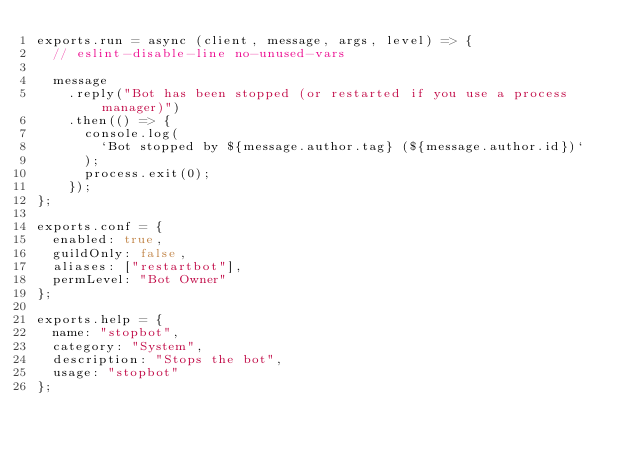<code> <loc_0><loc_0><loc_500><loc_500><_JavaScript_>exports.run = async (client, message, args, level) => {
  // eslint-disable-line no-unused-vars

  message
    .reply("Bot has been stopped (or restarted if you use a process manager)")
    .then(() => {
      console.log(
        `Bot stopped by ${message.author.tag} (${message.author.id})`
      );
      process.exit(0);
    });
};

exports.conf = {
  enabled: true,
  guildOnly: false,
  aliases: ["restartbot"],
  permLevel: "Bot Owner"
};

exports.help = {
  name: "stopbot",
  category: "System",
  description: "Stops the bot",
  usage: "stopbot"
};
</code> 